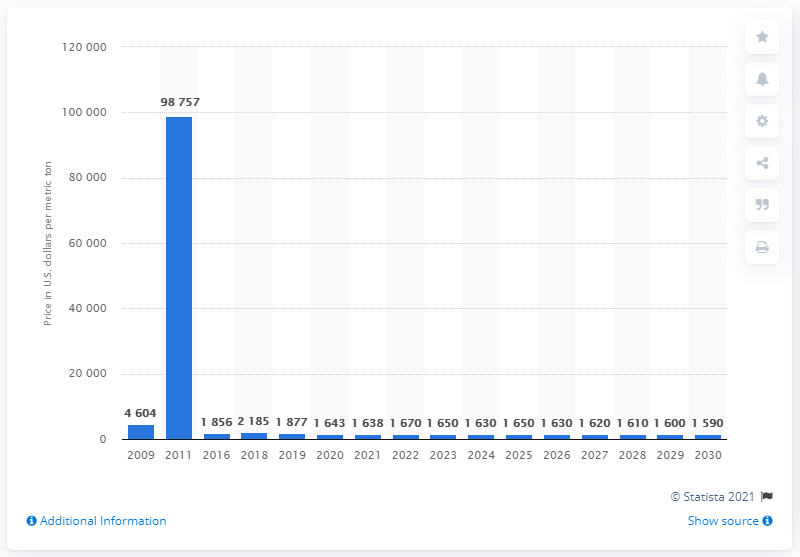Outline some significant characteristics in this image. The price of lanthanum oxide is expected to reach 1,638 U.S. dollars per metric ton in 2021. 